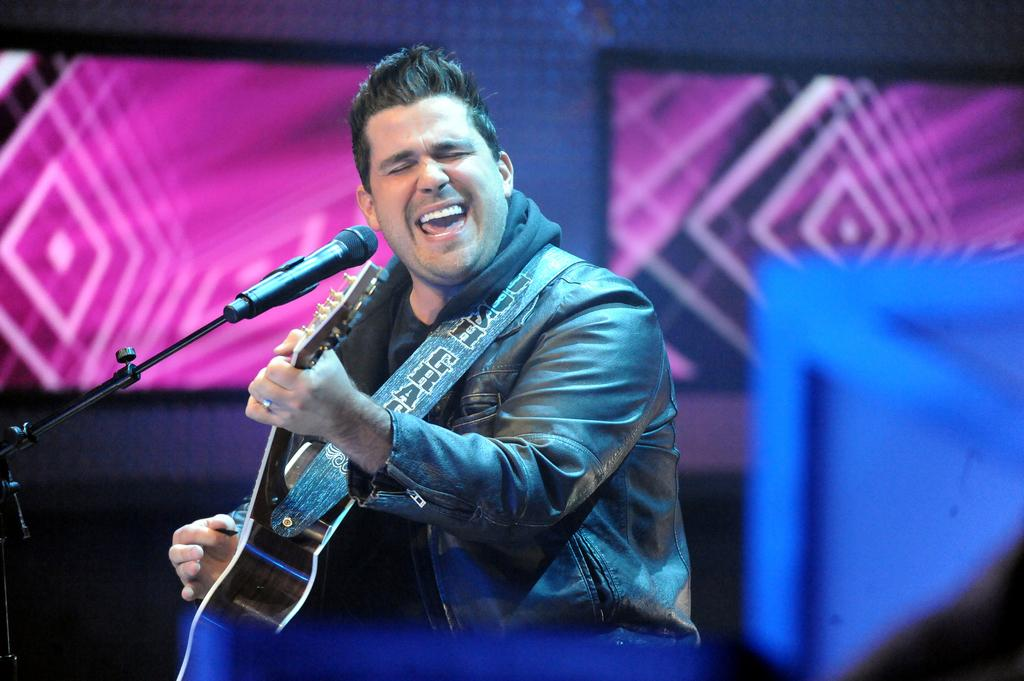Who is the main subject in the image? There is a man in the image. What is the man doing in the image? The man is singing and playing the guitar. What instrument is the man holding in the image? The man is holding a guitar. What device is present for amplifying the man's voice? There is a microphone in the image. How many rabbits are hopping around the man in the image? There are no rabbits present in the image. What thought is the man having while playing the guitar in the image? We cannot determine the man's thoughts from the image alone. 